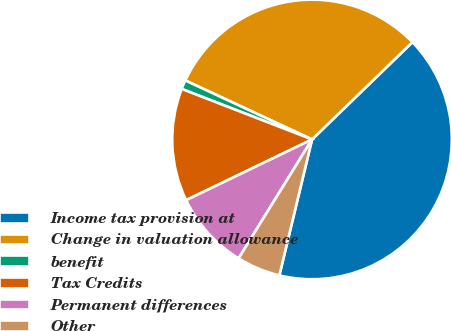Convert chart to OTSL. <chart><loc_0><loc_0><loc_500><loc_500><pie_chart><fcel>Income tax provision at<fcel>Change in valuation allowance<fcel>benefit<fcel>Tax Credits<fcel>Permanent differences<fcel>Other<nl><fcel>41.0%<fcel>30.81%<fcel>1.05%<fcel>13.04%<fcel>9.04%<fcel>5.05%<nl></chart> 